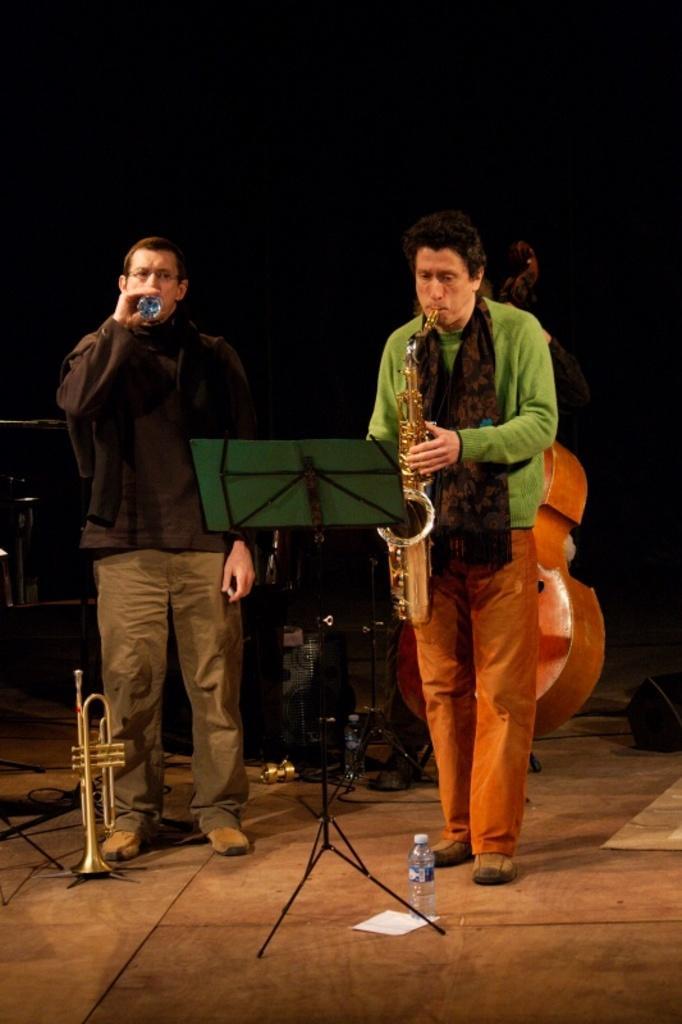How would you summarize this image in a sentence or two? In this picture a man is playing saxophone and another man is drinking water, in front of them we can see a stand and a bottle, in the background we can see a violin, and some musical instruments. 